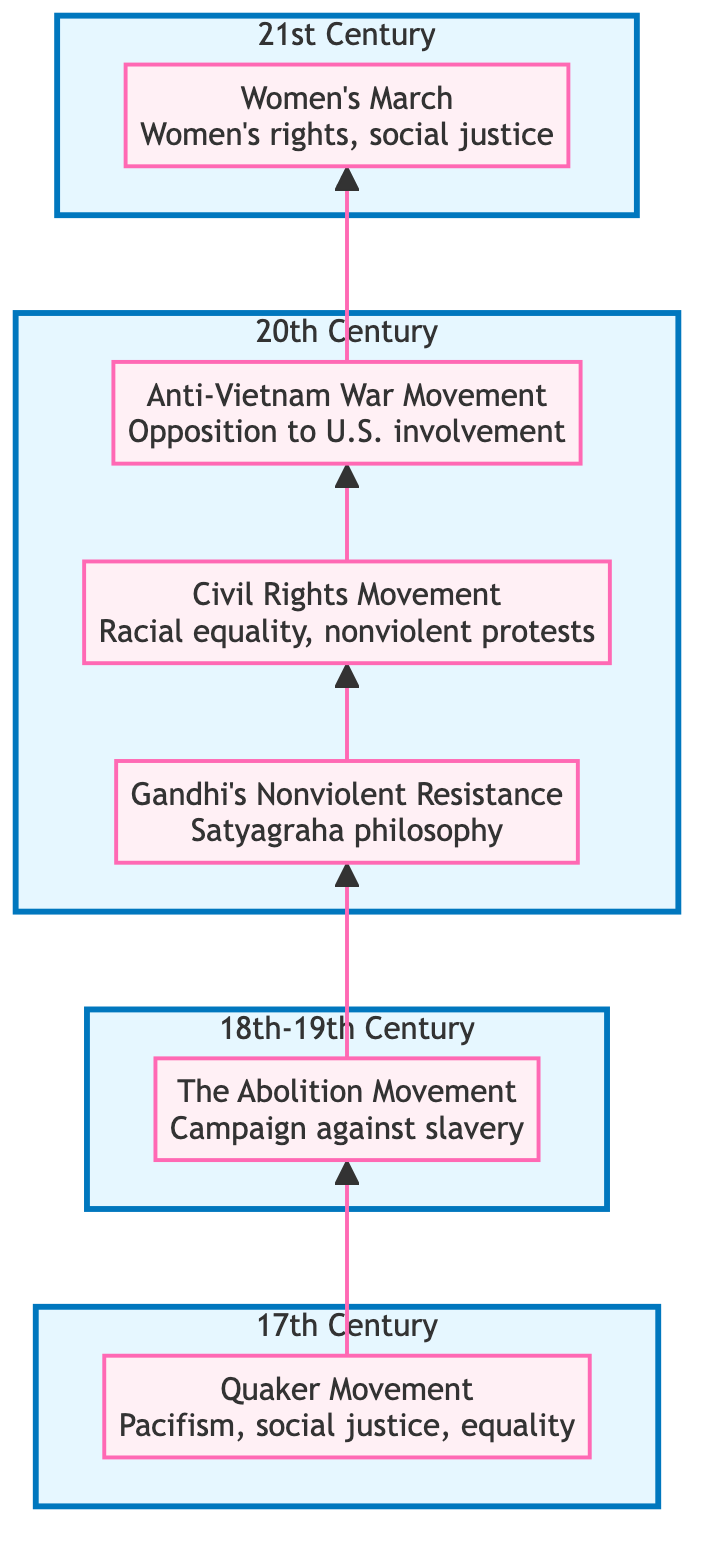What movement started in the 17th century? The diagram shows that the Quaker Movement is placed at the top in the 17th century section, indicating it as the defining movement for that time period.
Answer: Quaker Movement Which movement emphasizes Satyagraha philosophy? By examining the flow chart, Gandhi's Nonviolent Resistance is linked from the Abolition Movement and is described with the term "Satyagraha philosophy," indicating its focus on nonviolent resistance.
Answer: Gandhi's Nonviolent Resistance How many total movements are depicted in the diagram? Counting the nodes within the flowchart, we find six movements listed: Quaker Movement, The Abolition Movement, Gandhi's Nonviolent Resistance, Civil Rights Movement, Anti-Vietnam War Movement, and Women's March.
Answer: 6 What is the relationship between the Civil Rights Movement and the Anti-Vietnam War Movement? The diagram connects the Civil Rights Movement directly to the Anti-Vietnam War Movement, indicating a chronological flow where the former inspired or preceded the latter in advocacy for peace.
Answer: Sequentially linked Which movement is the latest among all movements in the chart? Observing the time periods of each movement, the Women's March is placed in the 21st Century, indicating that it is the most recent movement among those listed.
Answer: Women's March What major issue did the Abolition Movement address? The description for The Abolition Movement specifically states it was a "campaign against slavery," which identifies its primary focus and issue addressed during its time.
Answer: Slavery Which leader is associated with the Civil Rights Movement? The diagram indicates that the Civil Rights Movement includes notable leaders such as Martin Luther King Jr. and Rosa Parks, highlighting their contributions to the movement.
Answer: Martin Luther King Jr How do the Women’s March and the Anti-Vietnam War Movement relate in terms of timeline? By following the flow from the Anti-Vietnam War Movement to the Women’s March, it is clear that the latter comes after the former, establishing a timeline connection between the two movements.
Answer: Chronologically sequenced 